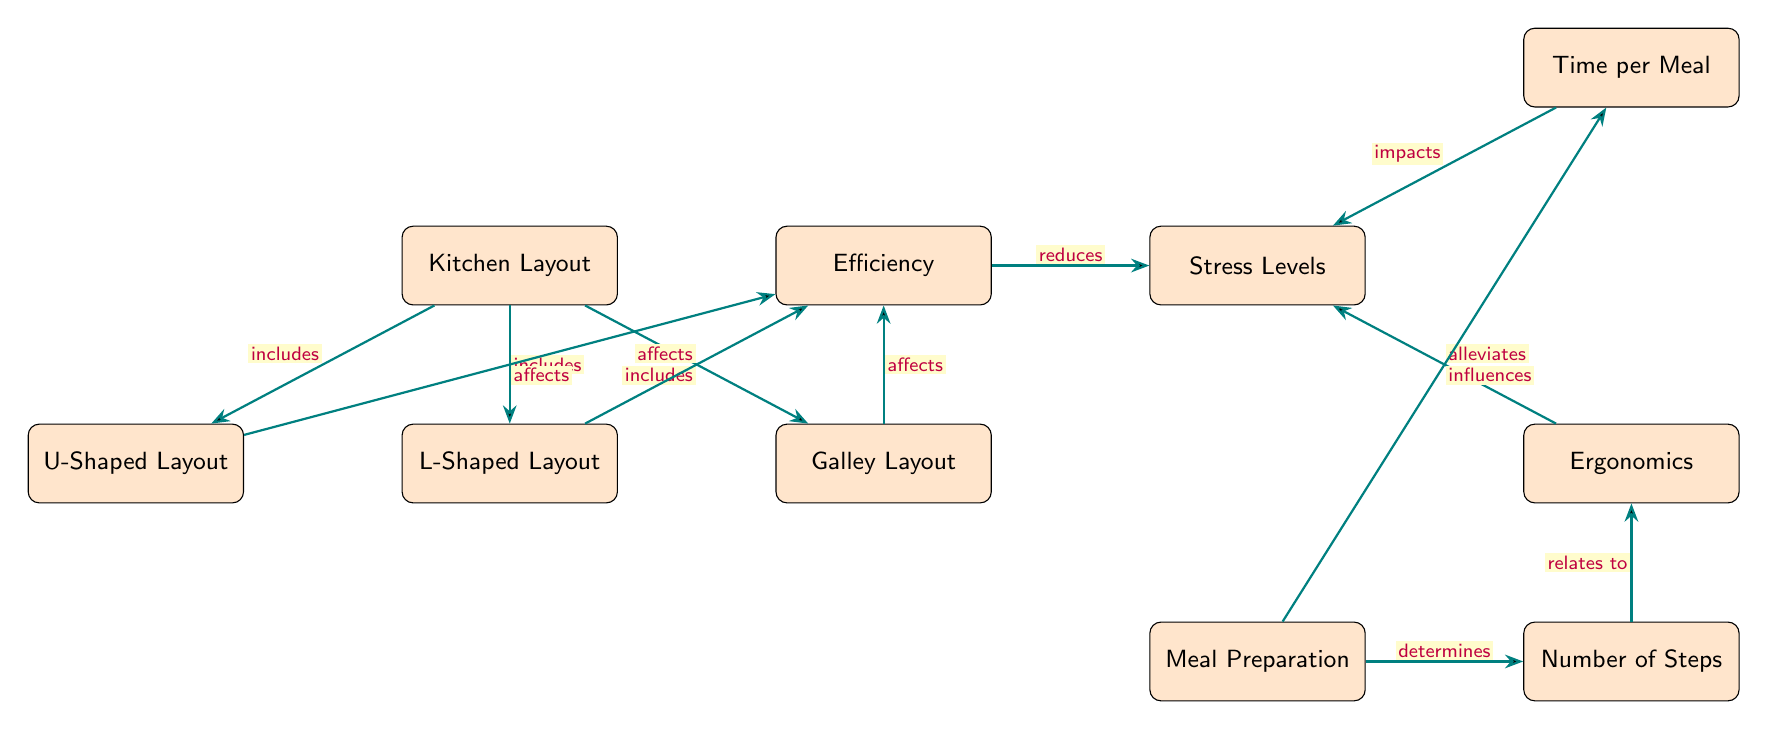What are the three kitchen layout types included in the diagram? The diagram lists three types of kitchen layouts: U-Shaped Layout, L-Shaped Layout, and Galley Layout. Each of these types is connected to the main node "Kitchen Layout" with an "includes" relation.
Answer: U-Shaped Layout, L-Shaped Layout, Galley Layout How does a U-Shaped Layout affect efficiency? According to the diagram, a U-Shaped Layout directly "affects" efficiency, which implies that it contributes positively or negatively to kitchen efficiency. The pathway labeled with "affects" connects U-Shaped Layout to efficiency.
Answer: Affects What two factors reduce stress levels according to the diagram? The diagram shows two arrows leading into the stress levels node: one from efficiency with the label "reduces" and another from ergonomics with the label "alleviates." Thus, both efficiency and ergonomics are factors contributing to reduced stress levels.
Answer: Efficiency, Ergonomics How does meal preparation influence time per meal? The diagram illustrates a direct connection from meal preparation to time per meal, marked with "influences." This indicates that the way a meal is prepared has a direct impact on the time taken to cook it.
Answer: Influences What relationship exists between the number of steps and ergonomics? The diagram specifies that the number of steps "relates to" ergonomics, which signifies that there is a defining connection between the two elements. The relation implies that the number of steps in a kitchen layout has an impact on how ergonomic the layout can be.
Answer: Relates to Which kitchen layout type do the arrows aiming towards efficiency connect? All three kitchen layout types—U-Shaped Layout, L-Shaped Layout, and Galley Layout—are depicted with arrows that affect efficiency. The connections indicate that any of these layouts can contribute to kitchen efficiency.
Answer: All three What is the connection between time per meal and stress levels? The diagram shows that time per meal "impacts" stress levels, indicating that the time it takes to prepare a meal has a significant effect on the stress experienced during cooking. Specifically, longer meal preparation times could lead to higher stress levels.
Answer: Impacts 